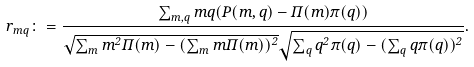<formula> <loc_0><loc_0><loc_500><loc_500>r _ { m q } \colon = \frac { \sum _ { m , q } m q ( P ( m , q ) - \Pi ( m ) \pi ( q ) ) } { \sqrt { \sum _ { m } m ^ { 2 } \Pi ( m ) - ( \sum _ { m } m \Pi ( m ) ) ^ { 2 } } \sqrt { \sum _ { q } q ^ { 2 } \pi ( q ) - ( \sum _ { q } q \pi ( q ) ) ^ { 2 } } } .</formula> 